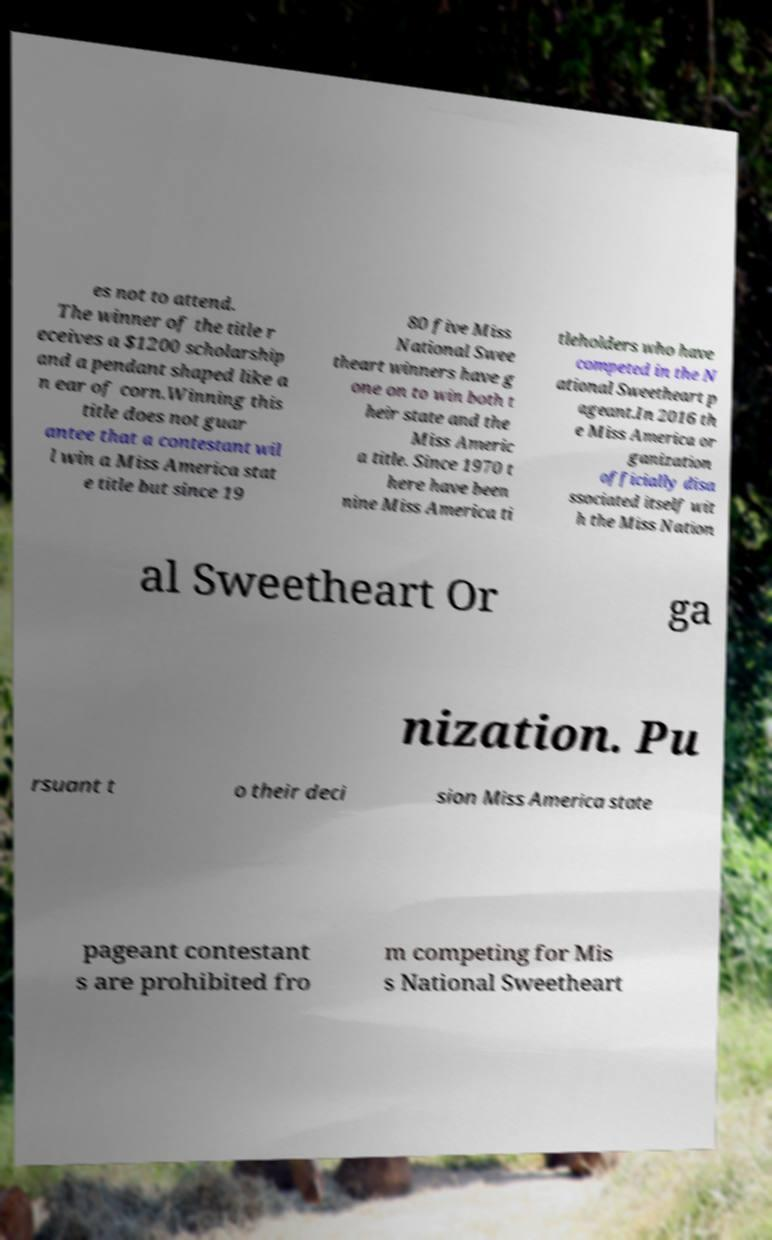Can you read and provide the text displayed in the image?This photo seems to have some interesting text. Can you extract and type it out for me? es not to attend. The winner of the title r eceives a $1200 scholarship and a pendant shaped like a n ear of corn.Winning this title does not guar antee that a contestant wil l win a Miss America stat e title but since 19 80 five Miss National Swee theart winners have g one on to win both t heir state and the Miss Americ a title. Since 1970 t here have been nine Miss America ti tleholders who have competed in the N ational Sweetheart p ageant.In 2016 th e Miss America or ganization officially disa ssociated itself wit h the Miss Nation al Sweetheart Or ga nization. Pu rsuant t o their deci sion Miss America state pageant contestant s are prohibited fro m competing for Mis s National Sweetheart 